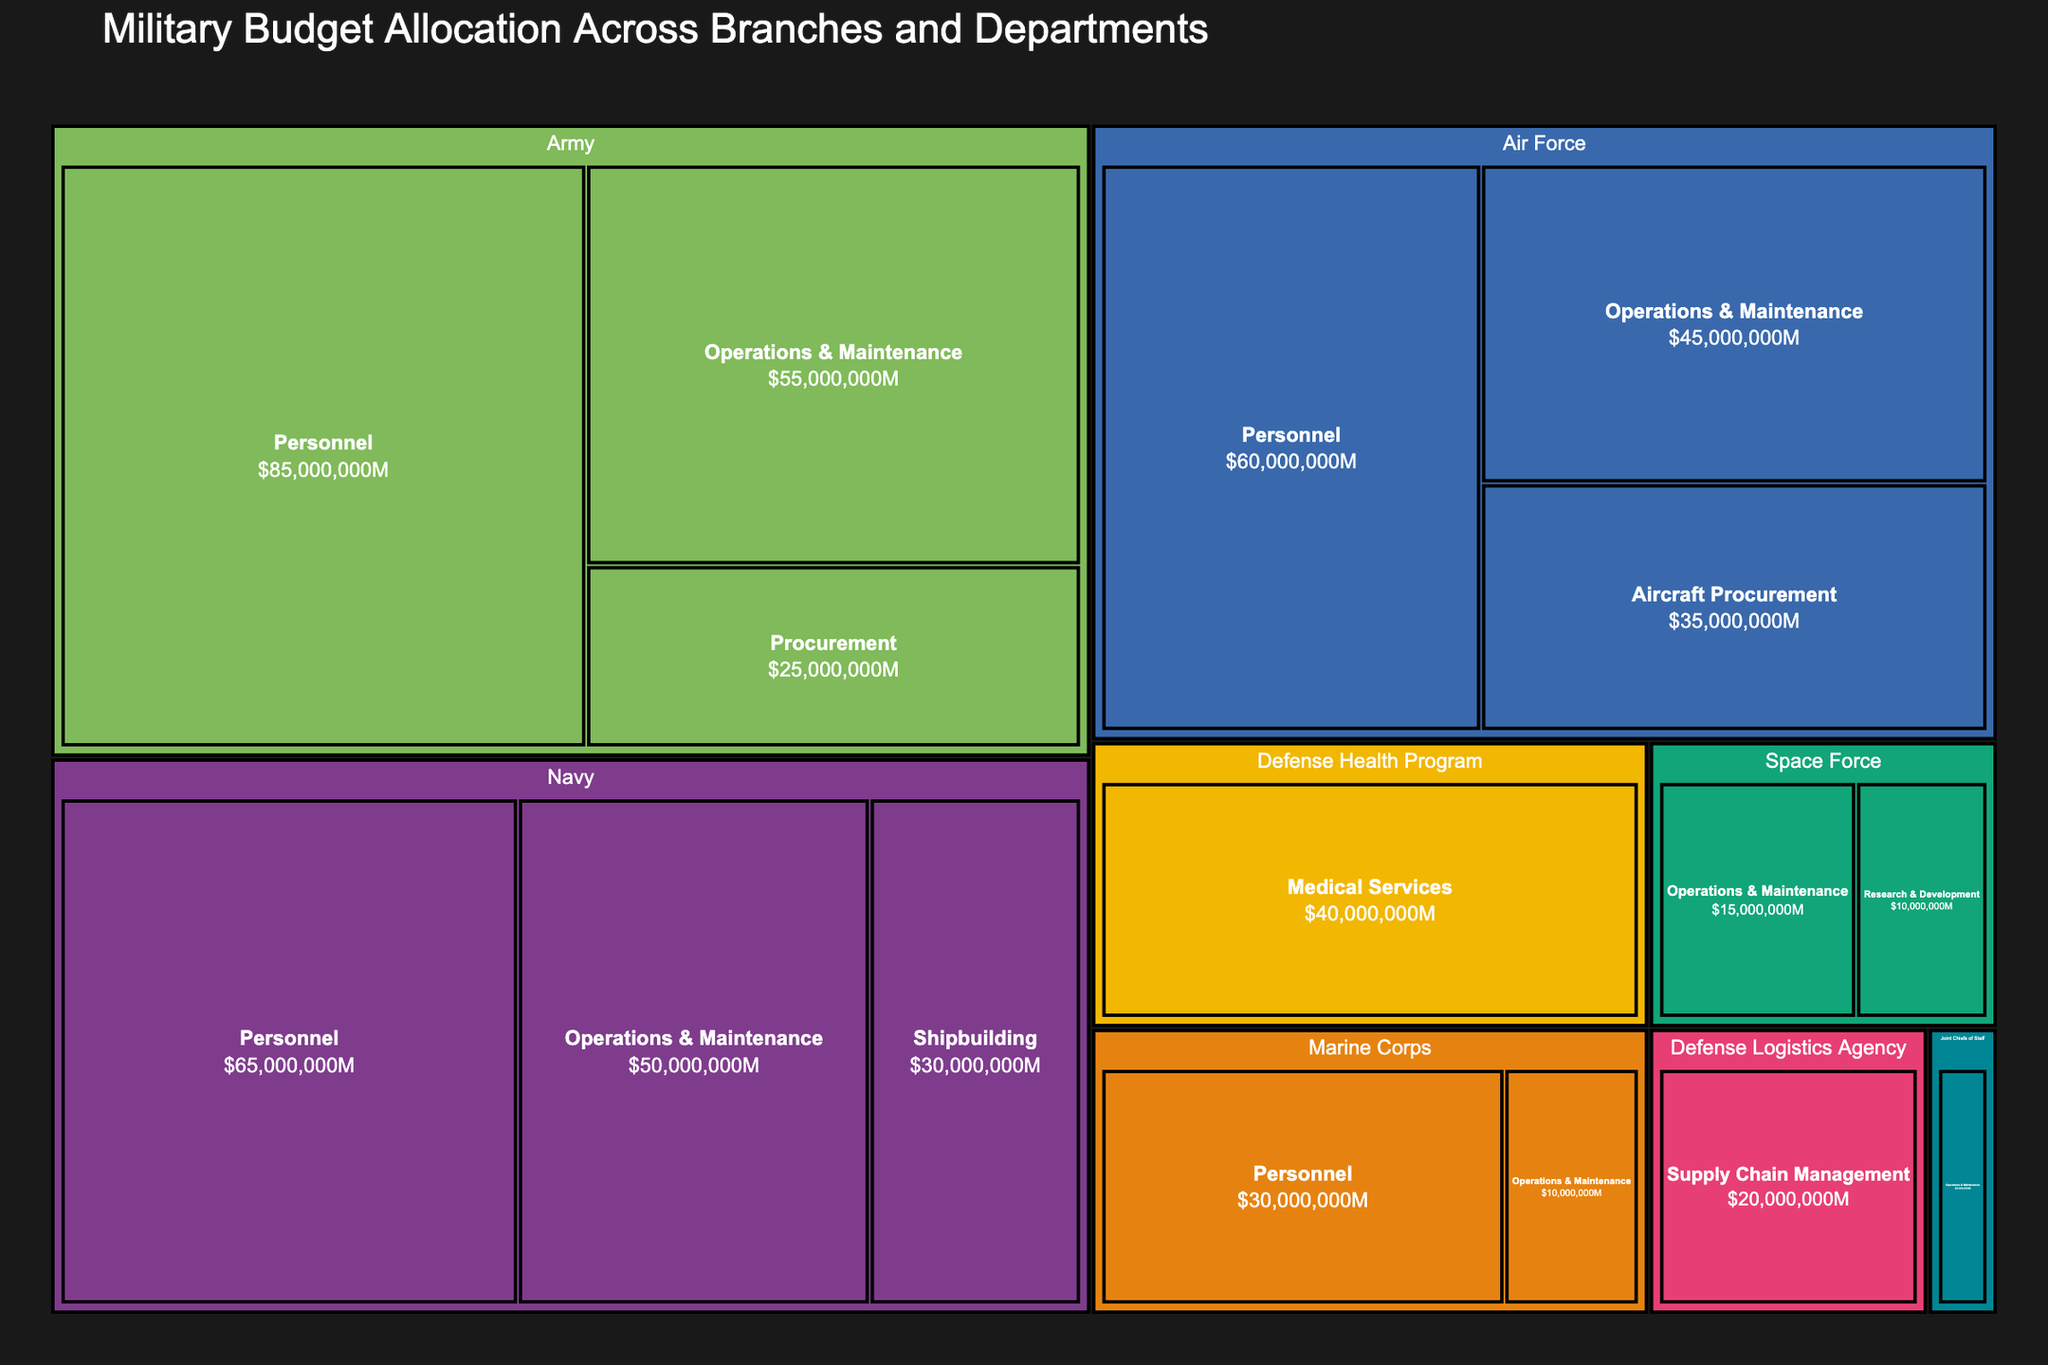What is the title of the figure? The title is located at the top of the treemap and is enlarged to provide a clear indication of the subject and data being displayed. The title reads "Military Budget Allocation Across Branches and Departments."
Answer: Military Budget Allocation Across Branches and Departments How much budget is allocated to the Operations & Maintenance department in the Army branch? First, locate the Army branch in the treemap. Under the Army branch, look for the Operations & Maintenance department and read the budget value displayed. It shows a budget of $55,000,000.
Answer: $55,000,000 Which branch has the highest budget allocated to Personnel? Examine each branch and identify the budget allocated to the Personnel department within each branch. The Army has the highest allocated budget to Personnel with $85,000,000.
Answer: Army What is the combined budget for the Space Force branch? Find and add the budget values for all departments under the Space Force branch. The Space Force has Operations & Maintenance with $15,000,000 and Research & Development with $10,000,000. So, the combined budget is $15,000,000 + $10,000,000 = $25,000,000.
Answer: $25,000,000 Which department has the smallest budget allocation, and how much is it? Look for the department with the smallest block in the treemap and read its budget value. The Joint Chiefs of Staff's Operations & Maintenance department has the smallest allocation with $5,000,000.
Answer: Joint Chiefs of Staff's Operations & Maintenance, $5,000,000 How does the budget allocation for the Navy's Operations & Maintenance department compare to the budget for Defense Health Program's Medical Services? Locate the budget values for each: Navy's Operations & Maintenance has $50,000,000, and Defense Health Program's Medical Services has $40,000,000. Compare these values to see that the Navy’s Operations & Maintenance has a larger budget by $10,000,000.
Answer: Navy's Operations & Maintenance is $10,000,000 more than Medical Services What's the total budget allocation for all the branches that have a Personnel department? Sum the budget allocations for the Personnel department across the Army ($85,000,000), Navy ($65,000,000), Air Force ($60,000,000), and Marine Corps ($30,000,000). The total budget is $85,000,000 + $65,000,000 + $60,000,000 + $30,000,000 = $240,000,000.
Answer: $240,000,000 Which branch has the largest overall budget allocation? Sum the budgets of each branch and compare. Army: $85,000,000 + $55,000,000 + $25,000,000 = $165,000,000; Navy: $65,000,000 + $50,000,000 + $30,000,000 = $145,000,000; Air Force: $60,000,000 + $45,000,000 + $35,000,000 = $140,000,000; Marine Corps: $30,000,000 + $10,000,000 = $40,000,000; Space Force: $25,000,000. Other departments are standalone. The Army has the largest overall allocation with $165,000,000.
Answer: Army 